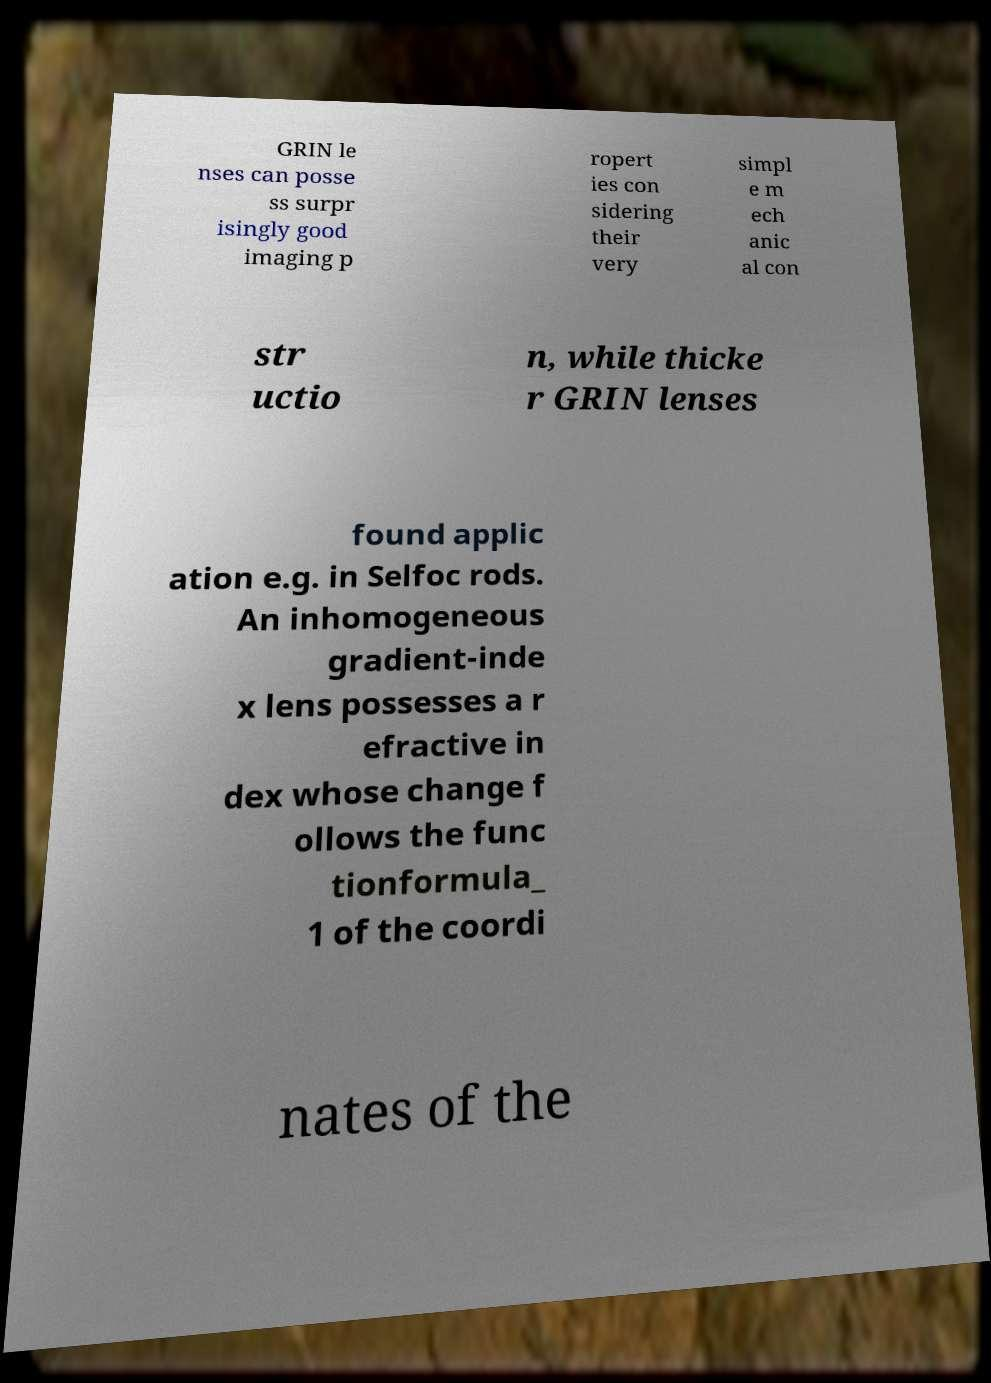Could you assist in decoding the text presented in this image and type it out clearly? GRIN le nses can posse ss surpr isingly good imaging p ropert ies con sidering their very simpl e m ech anic al con str uctio n, while thicke r GRIN lenses found applic ation e.g. in Selfoc rods. An inhomogeneous gradient-inde x lens possesses a r efractive in dex whose change f ollows the func tionformula_ 1 of the coordi nates of the 